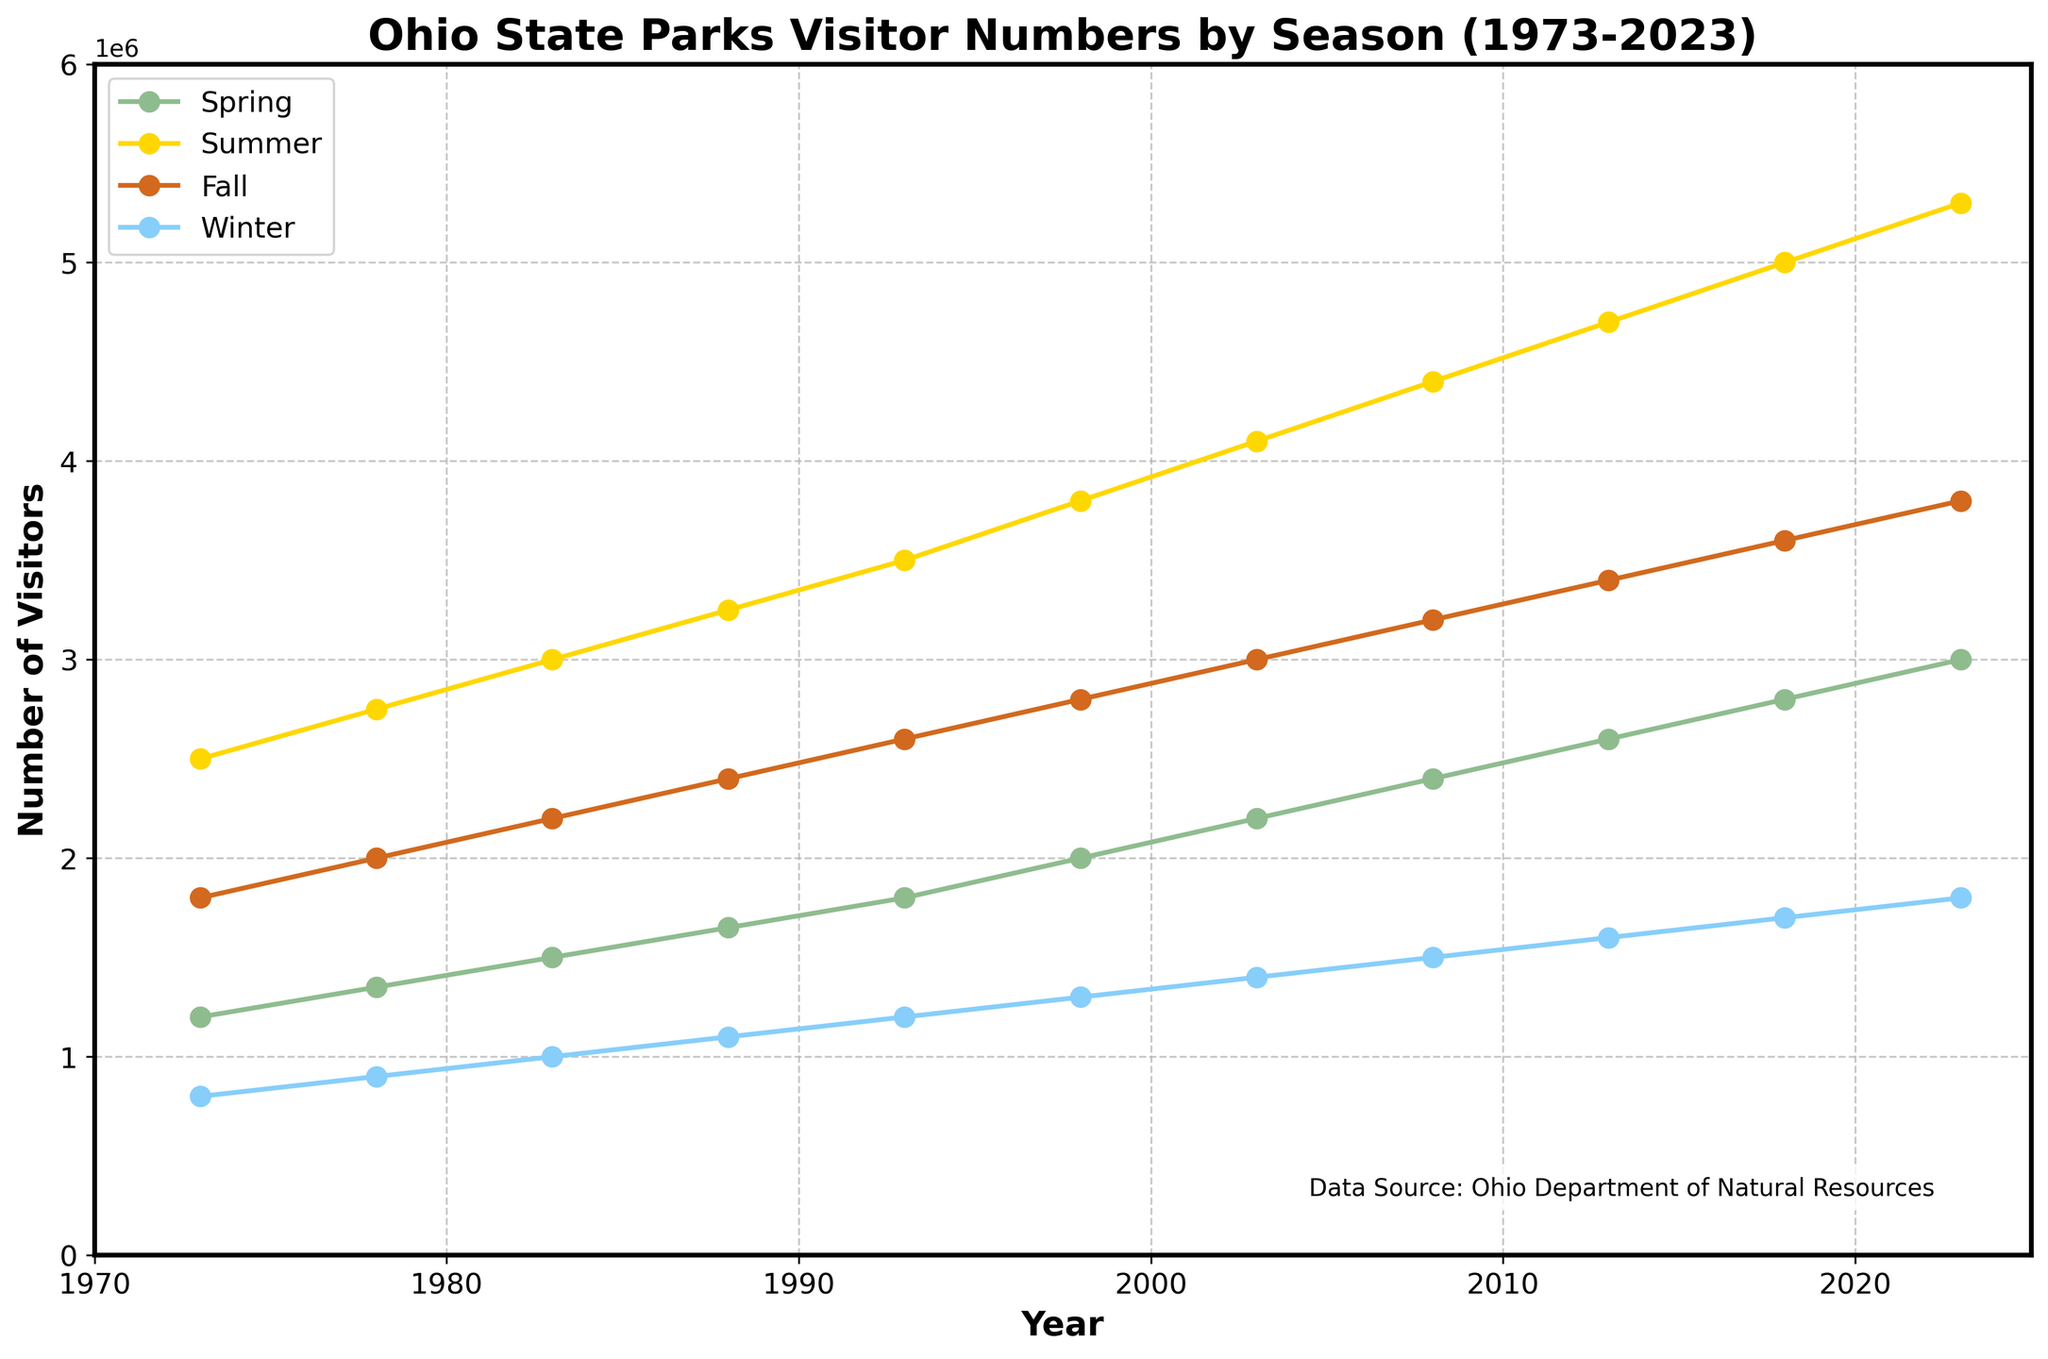What's the total number of visitors in 1993? The figure displays visitor numbers for each season in 1993. Sum them up: Spring (1,800,000) + Summer (3,500,000) + Fall (2,600,000) + Winter (1,200,000). 1,800,000 + 3,500,000 + 2,600,000 + 1,200,000 = 9,100,000
Answer: 9,100,000 Which season had the highest number of visitors in 2023? The highest line on the plot in 2023 is for Summer, which has the highest value among all seasons.
Answer: Summer By how much did the total number of visitors increase from 1973 to 2023? Find the total number of visitors in 1973 (6,300,000) and in 2023 (13,900,000), then calculate the difference: 13,900,000 - 6,300,000 = 7,600,000
Answer: 7,600,000 In which year did the Winter season first reach 1 million visitors? The plot shows the Winter season reaching 1 million visitors in 1983.
Answer: 1983 What is the average number of visitors for the Fall season over the given period? Sum the Fall visitor numbers over the years and divide by the number of years (11): (1,800,000 + 2,000,000 + 2,200,000 + 2,400,000 + 2,600,000 + 2,800,000 + 3,000,000 + 3,200,000 + 3,400,000 + 3,600,000 + 3,800,000) / 11 = 2,854,545
Answer: 2,854,545 Which season had the smallest number of visitors each year and how has its trend evolved? The Winter season consistently has the smallest number of visitors each year, based on the lowest line in the plot. Over 50 years, the number of Winter visitors has consistently increased.
Answer: Winter, increasing trend What is the trend for the Summer season from 1973 to 2023? The Summer season shows a consistent upward trend, with visitor numbers increasing each year from 2,500,000 in 1973 to 5,300,000 in 2023.
Answer: Increasing trend How much higher were the Summer visitors compared to Spring visitors in 2013? Subtract the number of Spring visitors in 2013 (2,600,000) from Summer visitors in 2013 (4,700,000). 4,700,000 - 2,600,000 = 2,100,000
Answer: 2,100,000 Which year had the highest total number of visitors, and what was the number? The highest point for total visitors is in 2023 with 13,900,000 visitors, as noted by the highest total value in the dataset.
Answer: 2023, 13,900,000 